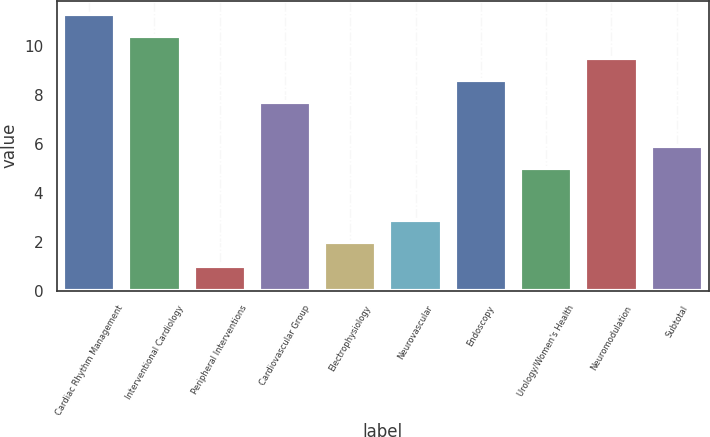Convert chart to OTSL. <chart><loc_0><loc_0><loc_500><loc_500><bar_chart><fcel>Cardiac Rhythm Management<fcel>Interventional Cardiology<fcel>Peripheral Interventions<fcel>Cardiovascular Group<fcel>Electrophysiology<fcel>Neurovascular<fcel>Endoscopy<fcel>Urology/Women's Health<fcel>Neuromodulation<fcel>Subtotal<nl><fcel>11.3<fcel>10.4<fcel>1<fcel>7.7<fcel>2<fcel>2.9<fcel>8.6<fcel>5<fcel>9.5<fcel>5.9<nl></chart> 